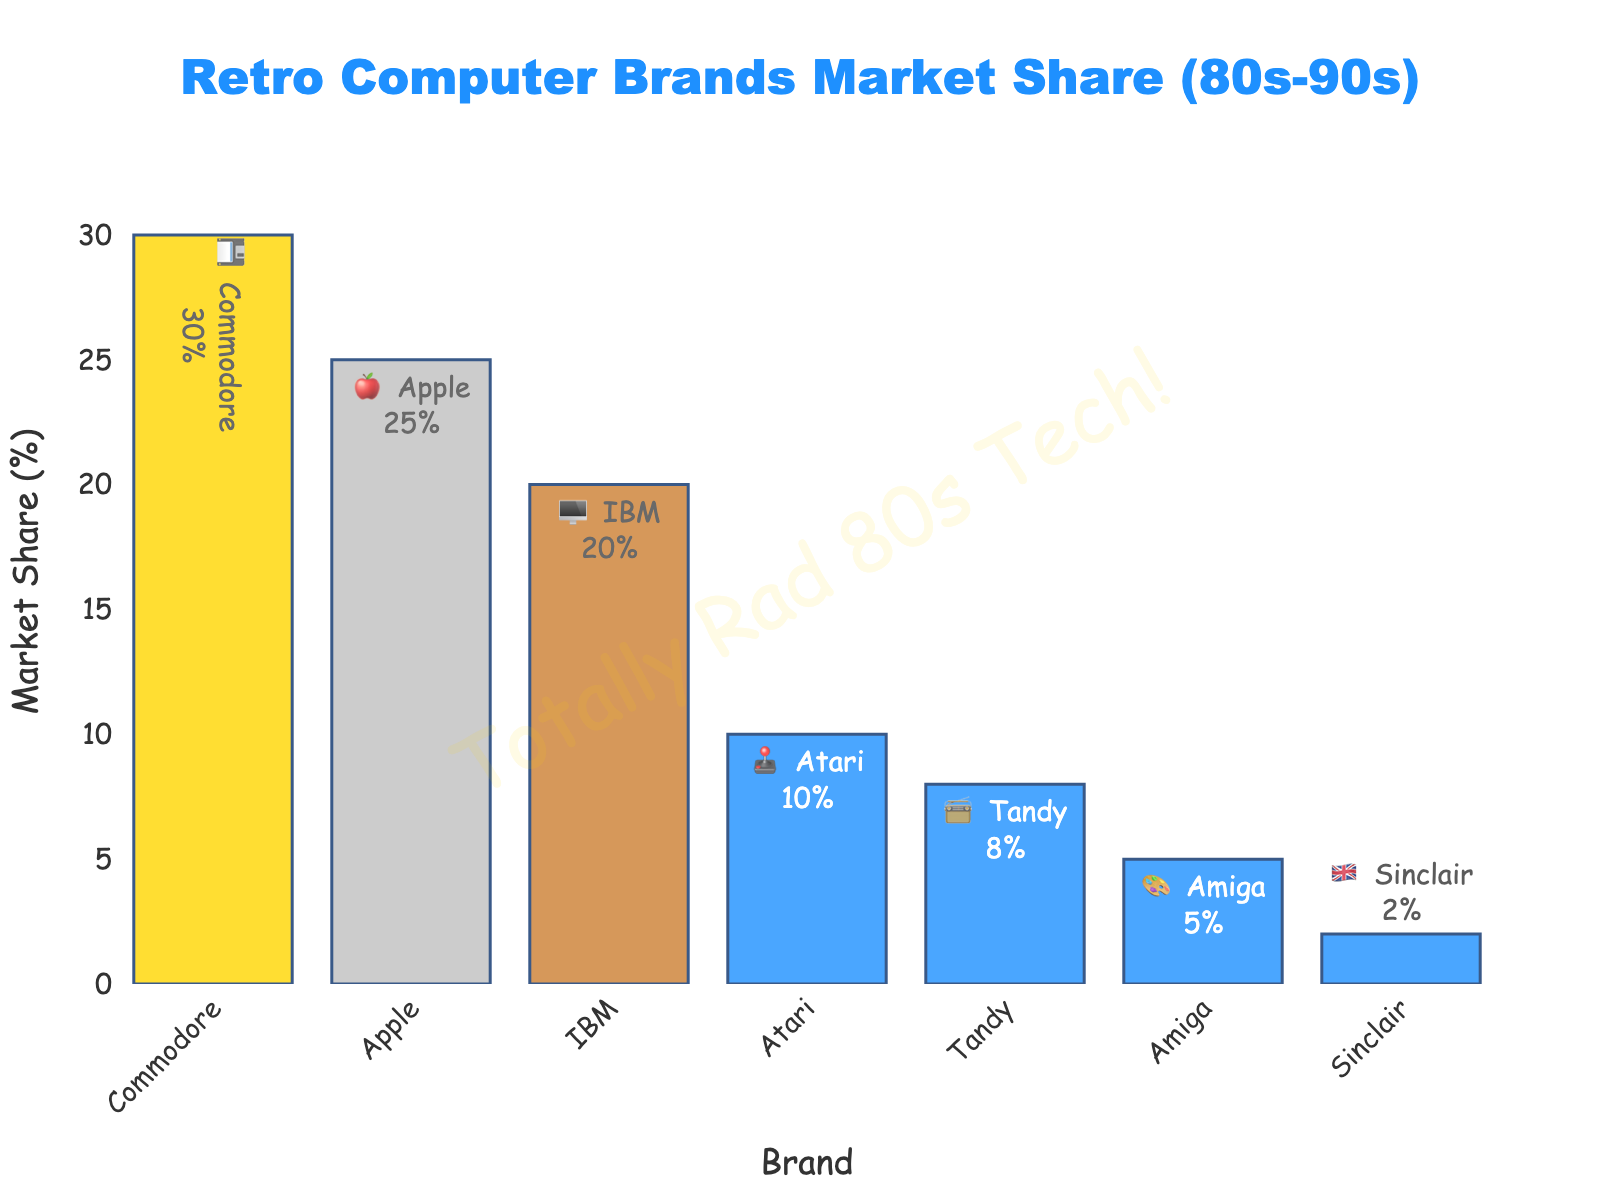What's the largest market share represented in the chart? The largest market share can be found by checking the highest value on the y-axis. We see Commodore with 30%.
Answer: 30% Which brand has a 10% market share and is represented with a joystick emoji? We need to look for the brand with the emoji 🕹️ and a 10% market share. This is Atari.
Answer: Atari What is the combined market share of Apple and IBM? Check the market shares of Apple and IBM: Apple has 25% and IBM has 20%. Adding these, we get 25% + 20% = 45%.
Answer: 45% How much larger is Commodore's market share compared to Amiga's? Commodore has 30% and Amiga has 5%. The difference is 30% - 5% = 25%.
Answer: 25% Which brand has the smallest market share, and what is its emoji? The smallest market share is 2%, represented by Sinclair with emoji 🇬🇧.
Answer: Sinclair, 🇬🇧 What is the median market share of the brands listed? The sorted market shares are 2, 5, 8, 10, 20, 25, 30. The median is the middle value, which is 10.
Answer: 10 How many brands have a market share of less than 10%? Counting the brands with market shares below 10%: Tandy (8%), Amiga (5%), and Sinclair (2%) makes it 3 brands.
Answer: 3 What is the total market share represented by the brands with an orange color bar? Summing up the market shares of the first three bars marked with gold, silver, and bronze colors: Commodore (30%), Apple (25%), IBM (20%) gives a total of 30 + 25 + 20 = 75%.
Answer: 75% What is the average market share of all the brands combined? Add all market shares: 30 + 25 + 20 + 10 + 8 + 5 + 2 = 100. There are 7 brands. The average market share is 100 / 7 ≈ 14.29%.
Answer: 14.29% Which brand uses the floppy disk emoji, and what is its market share? The emoji 💾 represents Commodore, which has a market share of 30%.
Answer: Commodore, 30% 